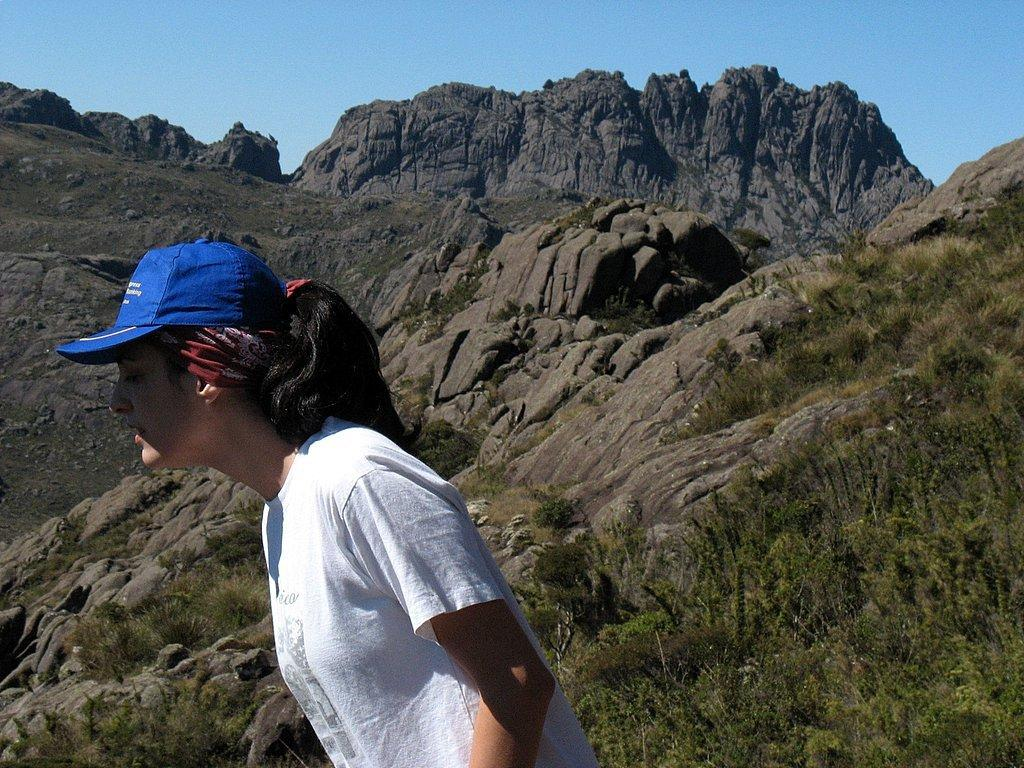Who is present in the image? There is a woman in the image. What is the woman wearing on her head? The woman is wearing a cap. What type of vegetation can be seen in the image? There is a group of plants and grass present in the image. What natural landmarks are visible in the image? Mountains are visible in the image. What is the weather like in the image? The sky is visible in the image, and it appears cloudy. What type of impulse can be seen affecting the plants in the image? There is no impulse affecting the plants in the image; they are stationary. What metal is used to create the note in the image? There is no note present in the image, so it is not possible to determine the metal used to create it. 